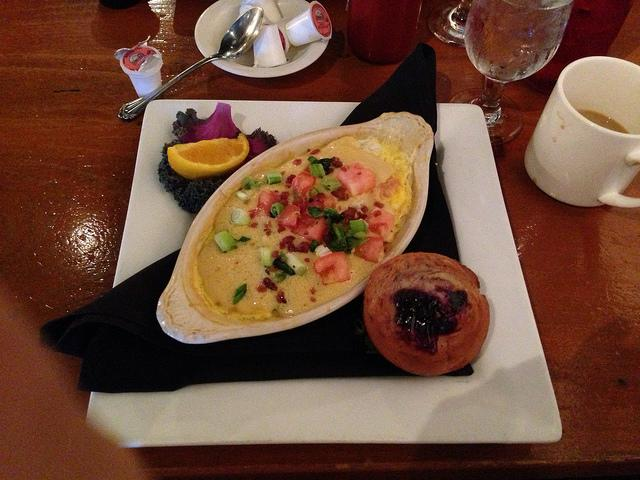What is in the little white plastic containers? creamer 